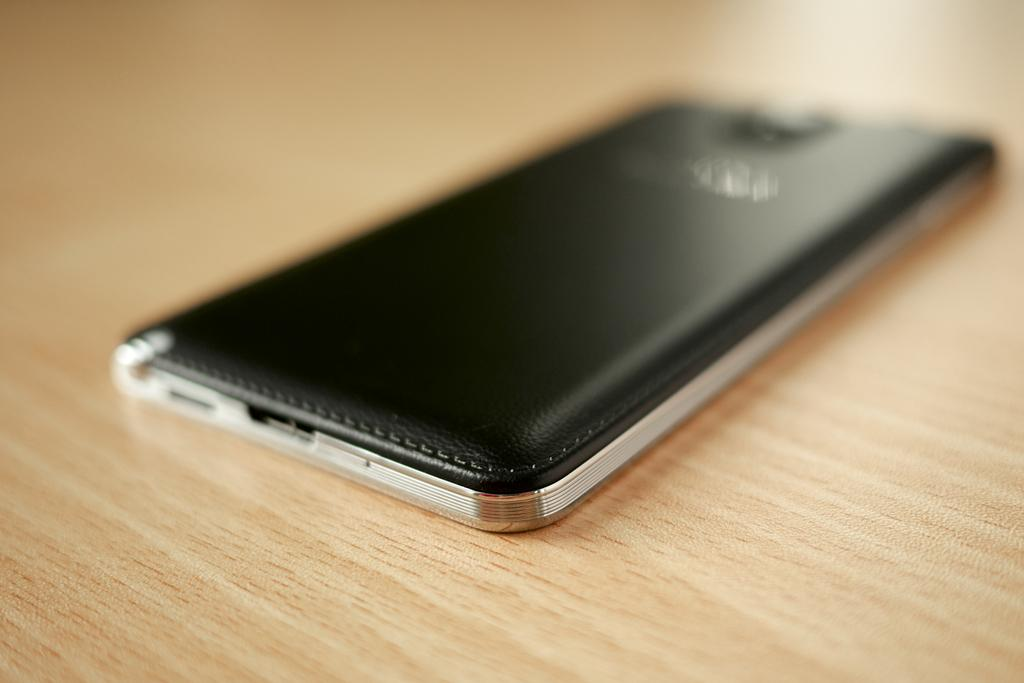What can be seen in the image? There is a device in the image. Where is the device located? The device is placed on a surface. Is there a baby holding the device in the image? There is no baby present in the image. 